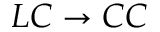<formula> <loc_0><loc_0><loc_500><loc_500>L C \to C C</formula> 